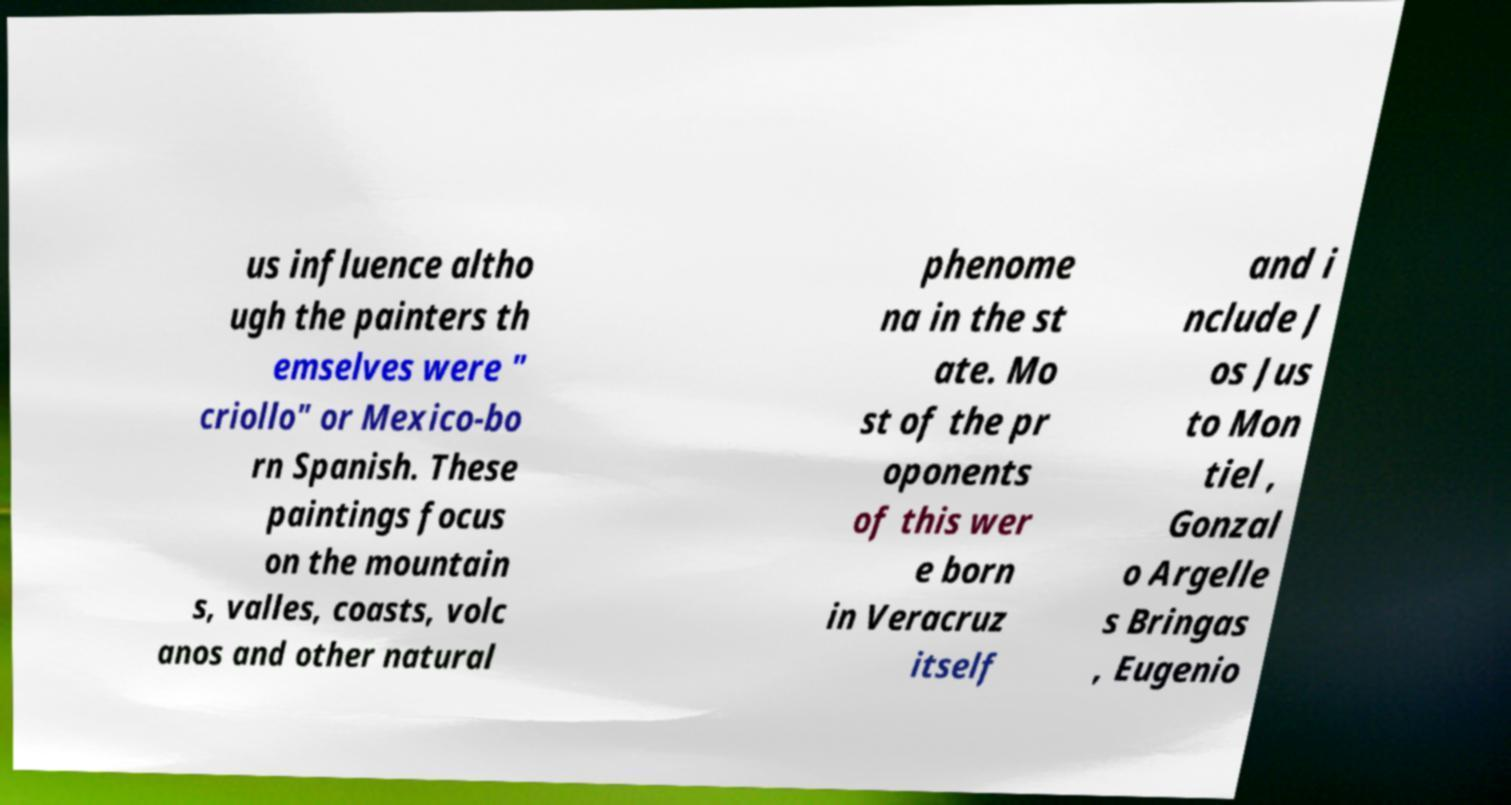Please read and relay the text visible in this image. What does it say? us influence altho ugh the painters th emselves were " criollo" or Mexico-bo rn Spanish. These paintings focus on the mountain s, valles, coasts, volc anos and other natural phenome na in the st ate. Mo st of the pr oponents of this wer e born in Veracruz itself and i nclude J os Jus to Mon tiel , Gonzal o Argelle s Bringas , Eugenio 